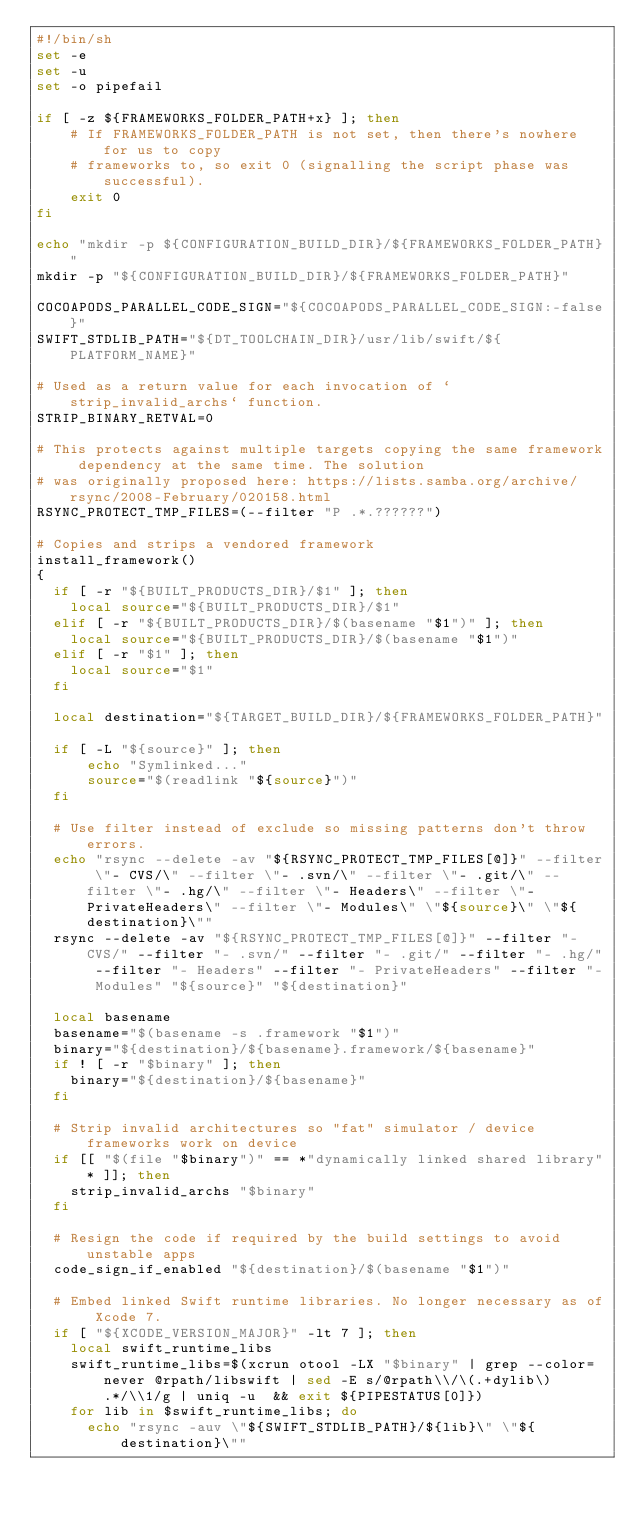<code> <loc_0><loc_0><loc_500><loc_500><_Bash_>#!/bin/sh
set -e
set -u
set -o pipefail

if [ -z ${FRAMEWORKS_FOLDER_PATH+x} ]; then
    # If FRAMEWORKS_FOLDER_PATH is not set, then there's nowhere for us to copy
    # frameworks to, so exit 0 (signalling the script phase was successful).
    exit 0
fi

echo "mkdir -p ${CONFIGURATION_BUILD_DIR}/${FRAMEWORKS_FOLDER_PATH}"
mkdir -p "${CONFIGURATION_BUILD_DIR}/${FRAMEWORKS_FOLDER_PATH}"

COCOAPODS_PARALLEL_CODE_SIGN="${COCOAPODS_PARALLEL_CODE_SIGN:-false}"
SWIFT_STDLIB_PATH="${DT_TOOLCHAIN_DIR}/usr/lib/swift/${PLATFORM_NAME}"

# Used as a return value for each invocation of `strip_invalid_archs` function.
STRIP_BINARY_RETVAL=0

# This protects against multiple targets copying the same framework dependency at the same time. The solution
# was originally proposed here: https://lists.samba.org/archive/rsync/2008-February/020158.html
RSYNC_PROTECT_TMP_FILES=(--filter "P .*.??????")

# Copies and strips a vendored framework
install_framework()
{
  if [ -r "${BUILT_PRODUCTS_DIR}/$1" ]; then
    local source="${BUILT_PRODUCTS_DIR}/$1"
  elif [ -r "${BUILT_PRODUCTS_DIR}/$(basename "$1")" ]; then
    local source="${BUILT_PRODUCTS_DIR}/$(basename "$1")"
  elif [ -r "$1" ]; then
    local source="$1"
  fi

  local destination="${TARGET_BUILD_DIR}/${FRAMEWORKS_FOLDER_PATH}"

  if [ -L "${source}" ]; then
      echo "Symlinked..."
      source="$(readlink "${source}")"
  fi

  # Use filter instead of exclude so missing patterns don't throw errors.
  echo "rsync --delete -av "${RSYNC_PROTECT_TMP_FILES[@]}" --filter \"- CVS/\" --filter \"- .svn/\" --filter \"- .git/\" --filter \"- .hg/\" --filter \"- Headers\" --filter \"- PrivateHeaders\" --filter \"- Modules\" \"${source}\" \"${destination}\""
  rsync --delete -av "${RSYNC_PROTECT_TMP_FILES[@]}" --filter "- CVS/" --filter "- .svn/" --filter "- .git/" --filter "- .hg/" --filter "- Headers" --filter "- PrivateHeaders" --filter "- Modules" "${source}" "${destination}"

  local basename
  basename="$(basename -s .framework "$1")"
  binary="${destination}/${basename}.framework/${basename}"
  if ! [ -r "$binary" ]; then
    binary="${destination}/${basename}"
  fi

  # Strip invalid architectures so "fat" simulator / device frameworks work on device
  if [[ "$(file "$binary")" == *"dynamically linked shared library"* ]]; then
    strip_invalid_archs "$binary"
  fi

  # Resign the code if required by the build settings to avoid unstable apps
  code_sign_if_enabled "${destination}/$(basename "$1")"

  # Embed linked Swift runtime libraries. No longer necessary as of Xcode 7.
  if [ "${XCODE_VERSION_MAJOR}" -lt 7 ]; then
    local swift_runtime_libs
    swift_runtime_libs=$(xcrun otool -LX "$binary" | grep --color=never @rpath/libswift | sed -E s/@rpath\\/\(.+dylib\).*/\\1/g | uniq -u  && exit ${PIPESTATUS[0]})
    for lib in $swift_runtime_libs; do
      echo "rsync -auv \"${SWIFT_STDLIB_PATH}/${lib}\" \"${destination}\""</code> 